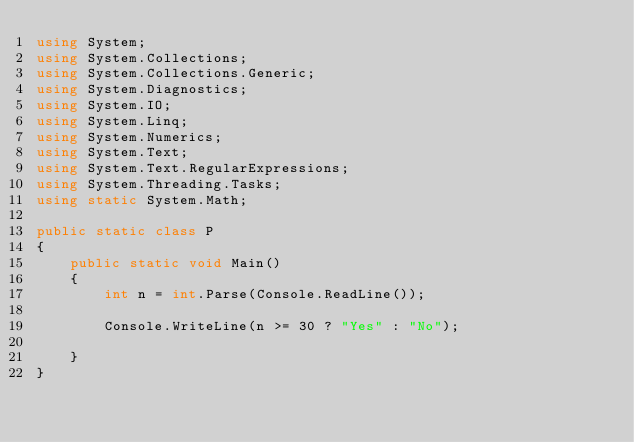Convert code to text. <code><loc_0><loc_0><loc_500><loc_500><_C#_>using System;
using System.Collections;
using System.Collections.Generic;
using System.Diagnostics;
using System.IO;
using System.Linq;
using System.Numerics;
using System.Text;
using System.Text.RegularExpressions;
using System.Threading.Tasks;
using static System.Math;

public static class P
{
    public static void Main()
    {
        int n = int.Parse(Console.ReadLine());

        Console.WriteLine(n >= 30 ? "Yes" : "No");
        
    }
}
</code> 